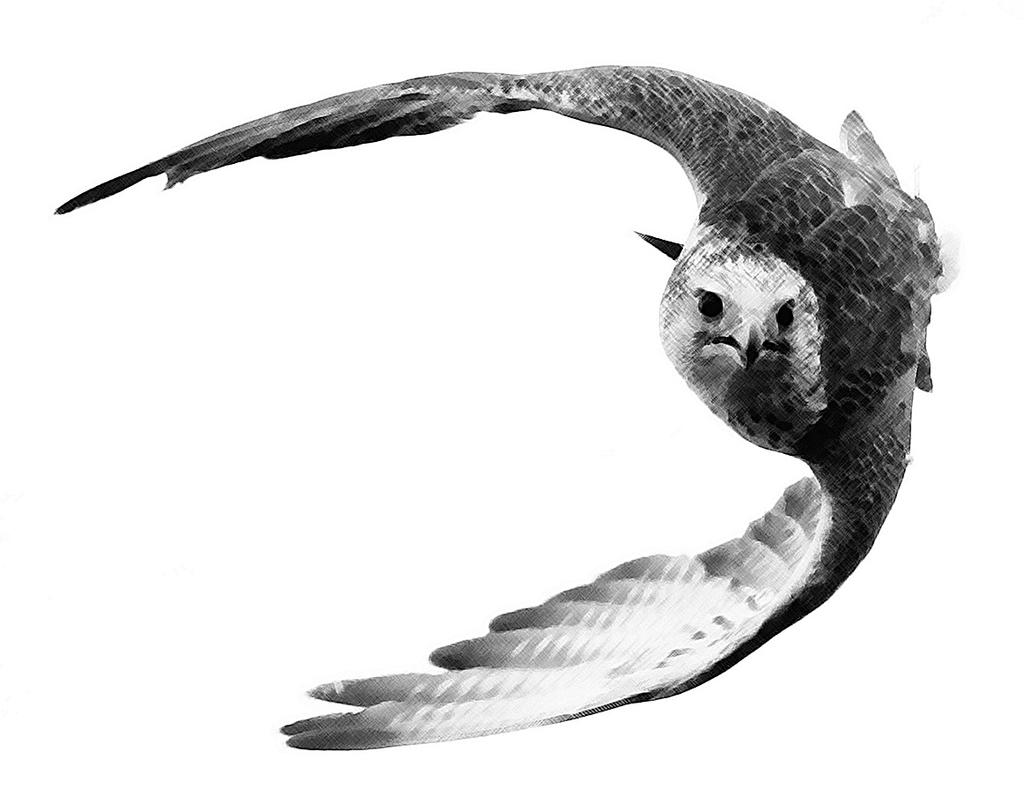What animal is featured in the image? There is an eagle in the image. What color is the background of the image? The background of the image is white. What color scheme is used in the image? The image is black and white. What type of jeans is the eagle wearing in the image? There are no jeans present in the image, as the eagle is a bird and does not wear clothing. 